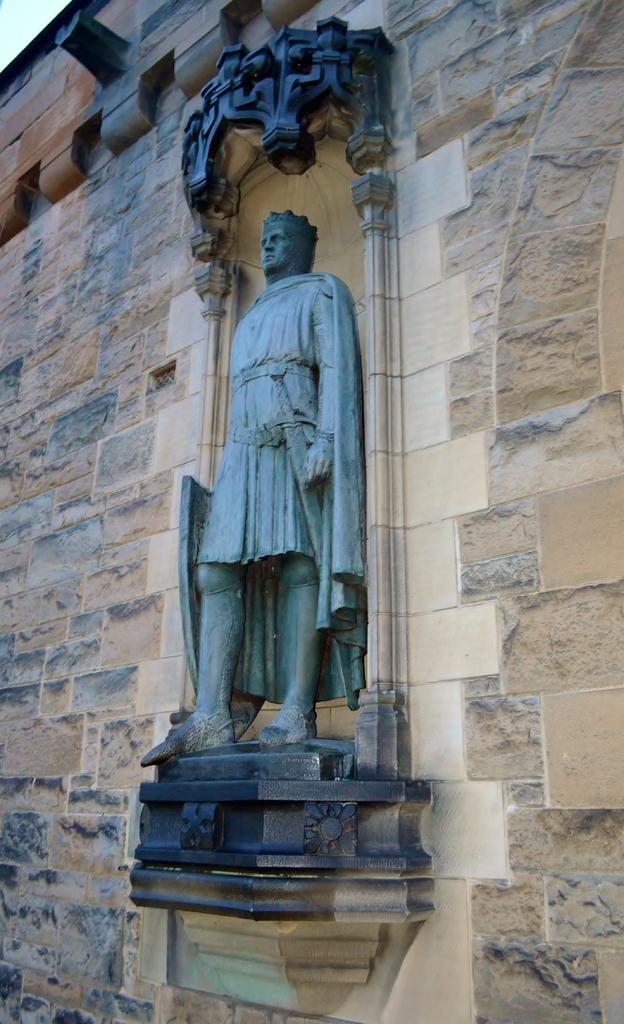In one or two sentences, can you explain what this image depicts? In the picture we can see a wall of historical construction and a sculpture man on it with a design and it is in the black color. 